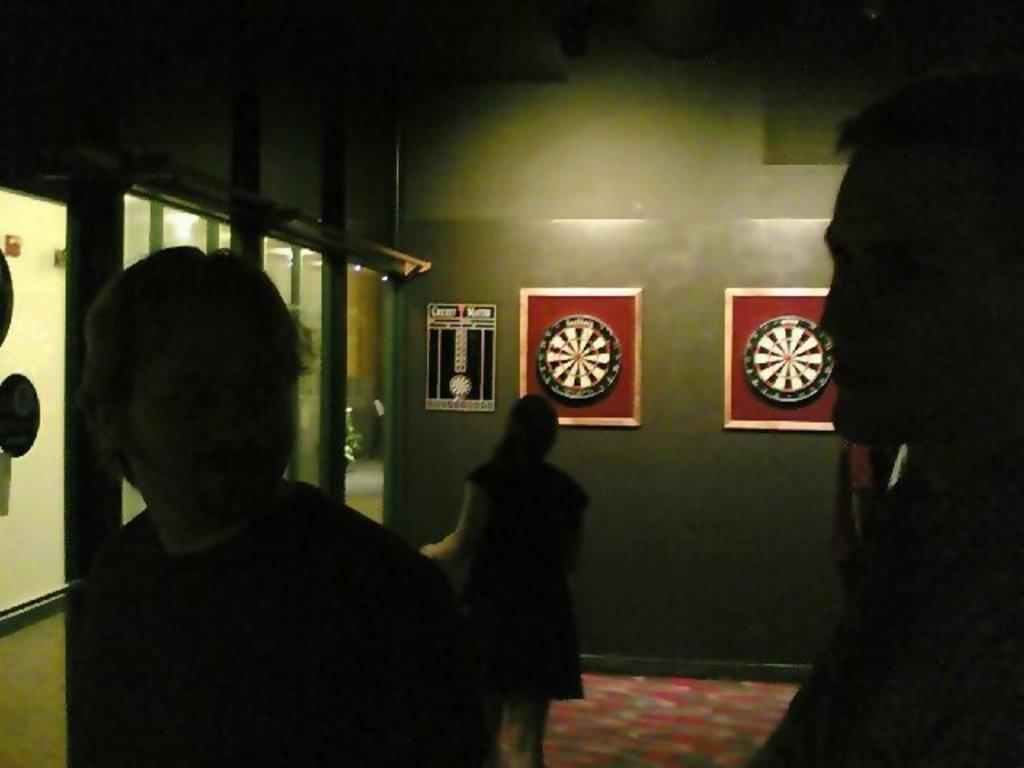Who or what can be seen in the image? There are people in the image. What part of the room is visible in the image? The floor is visible in the image. What architectural feature is present in the image? There is a wall in the image. What objects are present that might be used for seeing or drinking? Glasses are present in the image. What objects are visible that might hold pictures or artwork? Frames are visible in the image. What type of book is being used as a rod to stir sugar in the image? There is no book, rod, or sugar present in the image. 